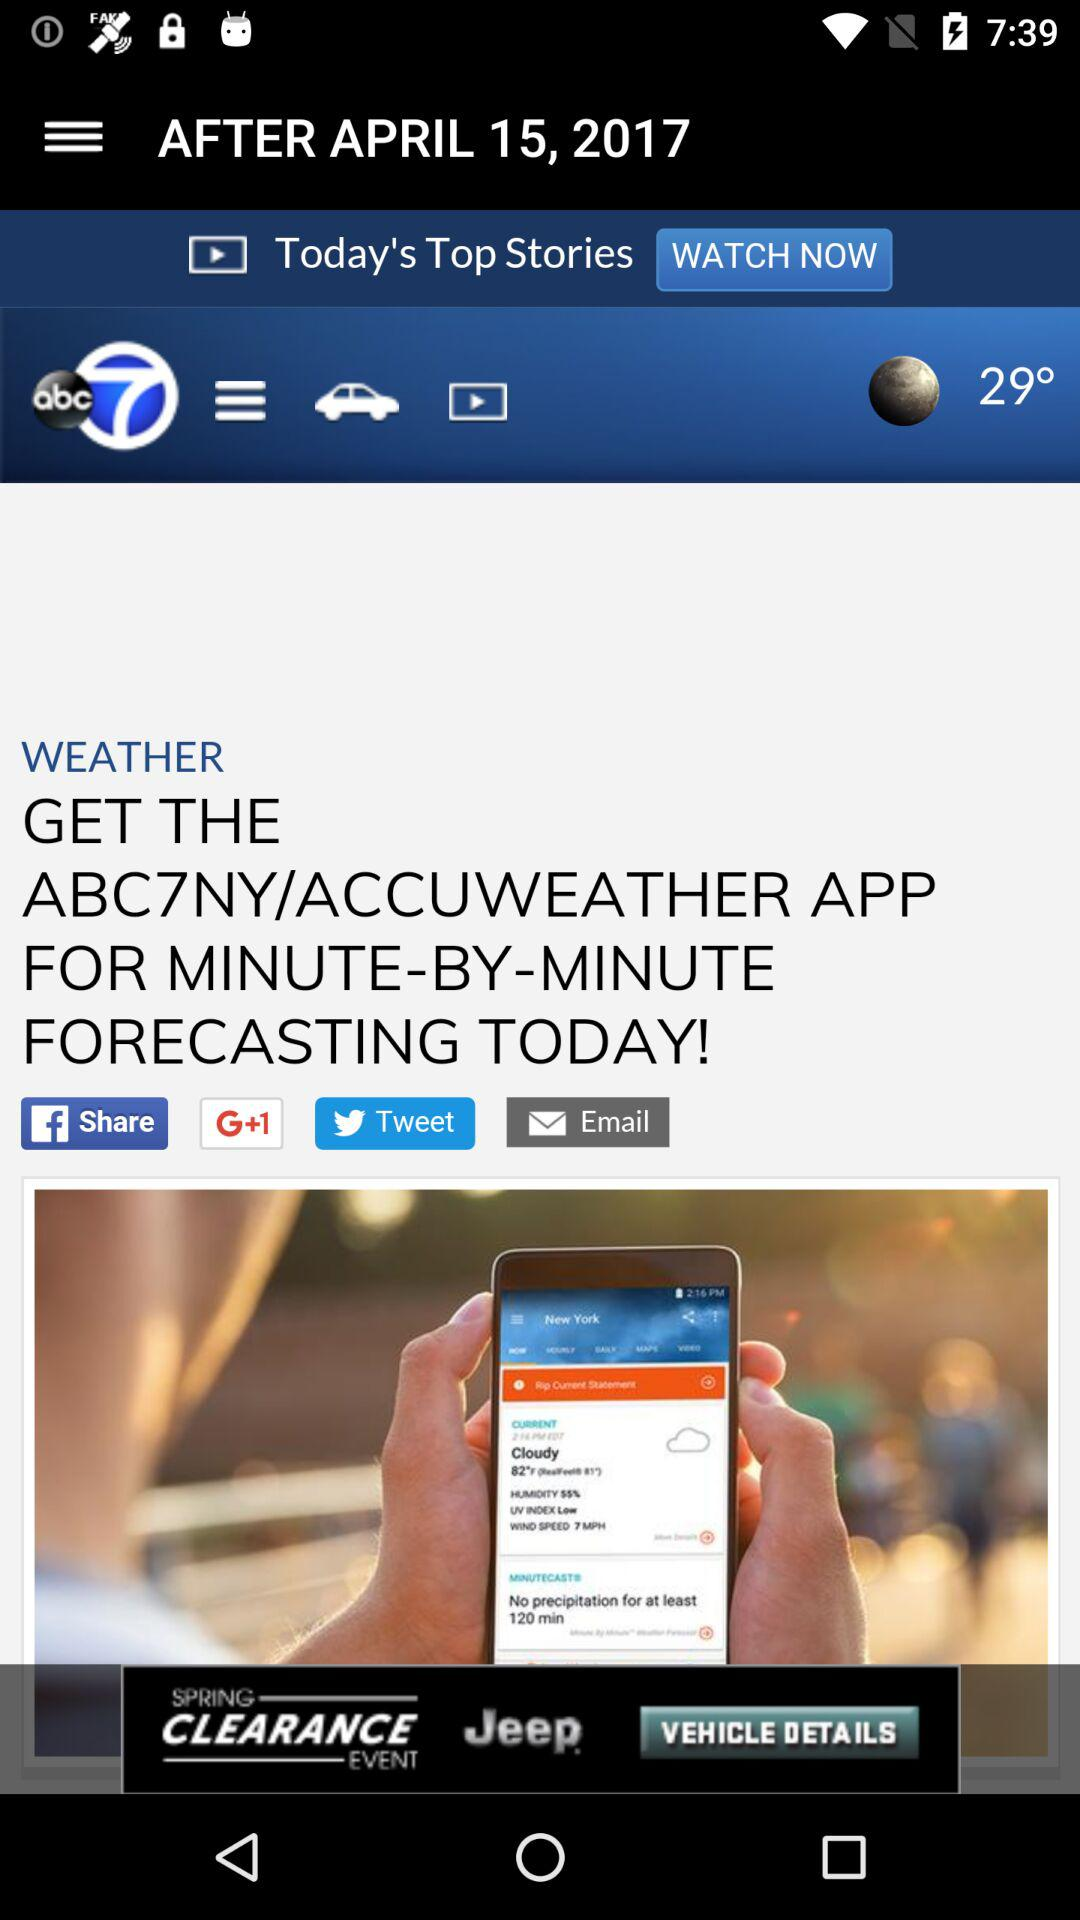What is the headline of the news? The headline of the news is "GET THE ABC7NY/ACCUWEATHER APP FOR MINUTE-BY-MINUTE FORECASTING TODAY!". 